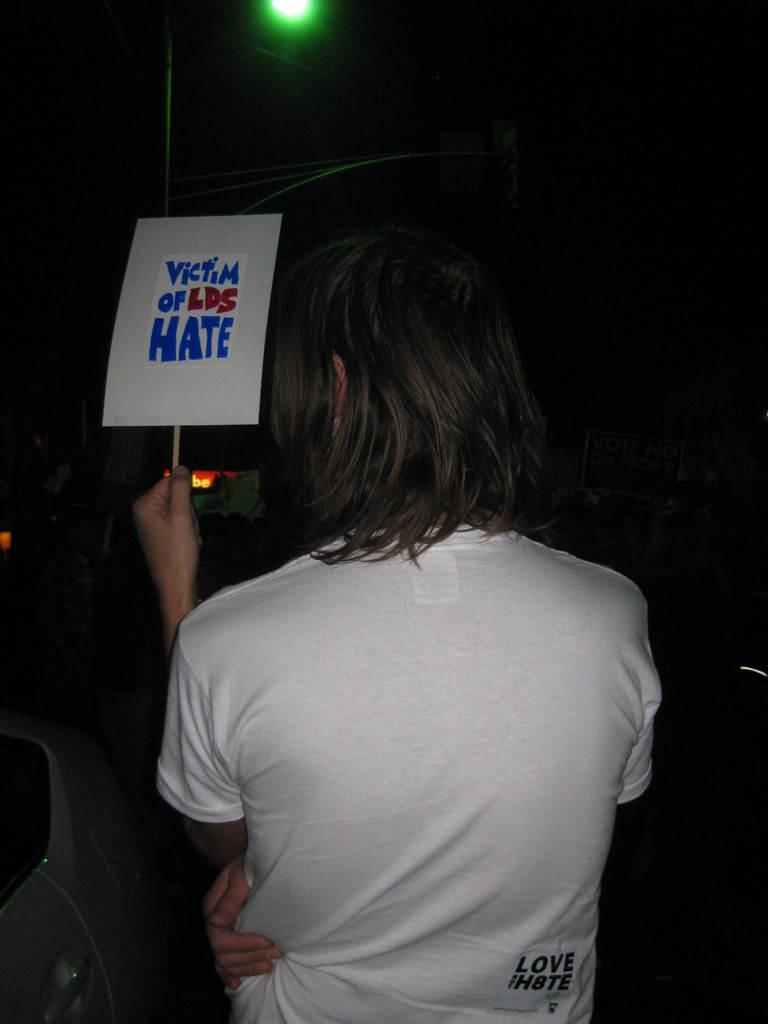What is the person in the image holding? The person is holding a poster in the image. What can be seen in front of the person? There is a light and some objects in front of the person. What is the lighting condition in the image? The background of the image is dark. How many beds can be seen in the image? There are no beds present in the image. What type of muscle is the person exercising in the image? There is no indication of exercise or muscle activity in the image. 